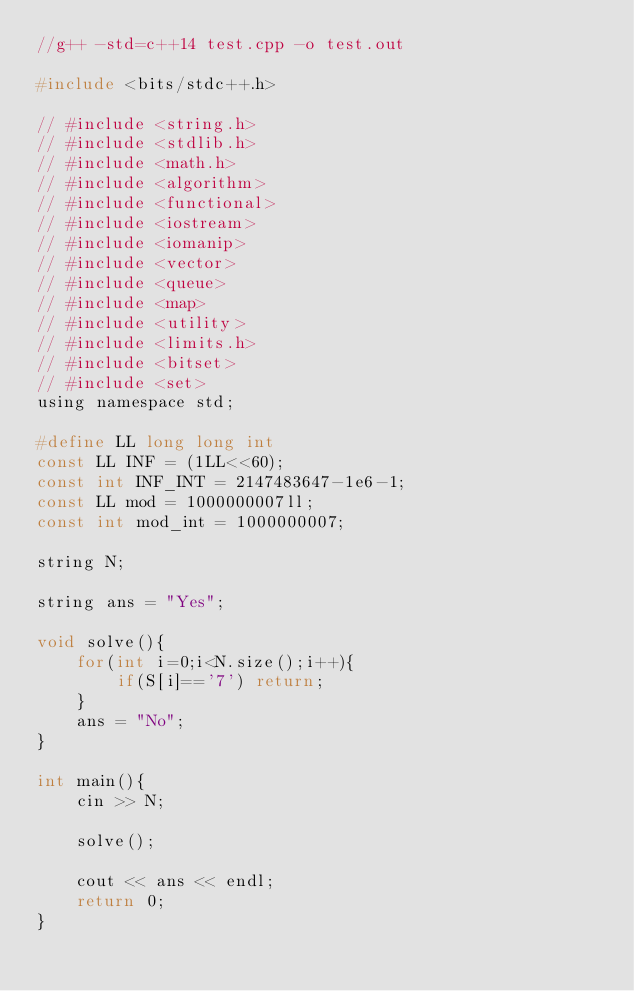<code> <loc_0><loc_0><loc_500><loc_500><_C_>//g++ -std=c++14 test.cpp -o test.out

#include <bits/stdc++.h>
 
// #include <string.h>
// #include <stdlib.h>
// #include <math.h>
// #include <algorithm>
// #include <functional>
// #include <iostream>
// #include <iomanip>
// #include <vector>
// #include <queue>
// #include <map> 
// #include <utility>
// #include <limits.h>
// #include <bitset>
// #include <set>
using namespace std;
 
#define LL long long int
const LL INF = (1LL<<60);
const int INF_INT = 2147483647-1e6-1;
const LL mod = 1000000007ll;
const int mod_int = 1000000007;
 
string N;
 
string ans = "Yes";
 
void solve(){
	for(int i=0;i<N.size();i++){
		if(S[i]=='7') return;
	}
	ans = "No";
}
 
int main(){
    cin >> N;
 
    solve();
 
    cout << ans << endl;
    return 0;
}</code> 